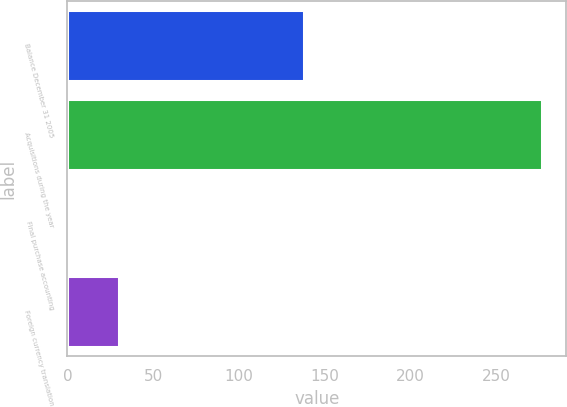Convert chart. <chart><loc_0><loc_0><loc_500><loc_500><bar_chart><fcel>Balance December 31 2005<fcel>Acquisitions during the year<fcel>Final purchase accounting<fcel>Foreign currency translation<nl><fcel>138.2<fcel>277<fcel>0.1<fcel>29.9<nl></chart> 